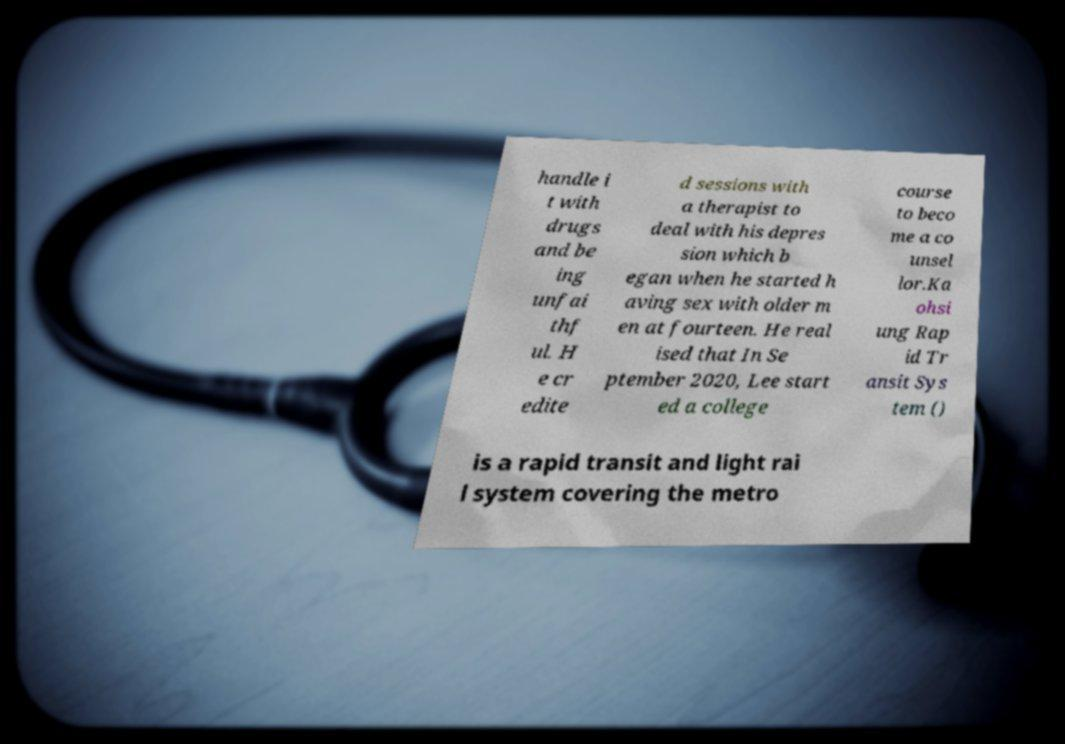For documentation purposes, I need the text within this image transcribed. Could you provide that? handle i t with drugs and be ing unfai thf ul. H e cr edite d sessions with a therapist to deal with his depres sion which b egan when he started h aving sex with older m en at fourteen. He real ised that In Se ptember 2020, Lee start ed a college course to beco me a co unsel lor.Ka ohsi ung Rap id Tr ansit Sys tem () is a rapid transit and light rai l system covering the metro 